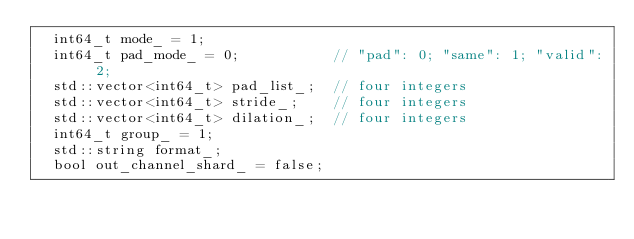Convert code to text. <code><loc_0><loc_0><loc_500><loc_500><_C_>  int64_t mode_ = 1;
  int64_t pad_mode_ = 0;           // "pad": 0; "same": 1; "valid": 2;
  std::vector<int64_t> pad_list_;  // four integers
  std::vector<int64_t> stride_;    // four integers
  std::vector<int64_t> dilation_;  // four integers
  int64_t group_ = 1;
  std::string format_;
  bool out_channel_shard_ = false;</code> 